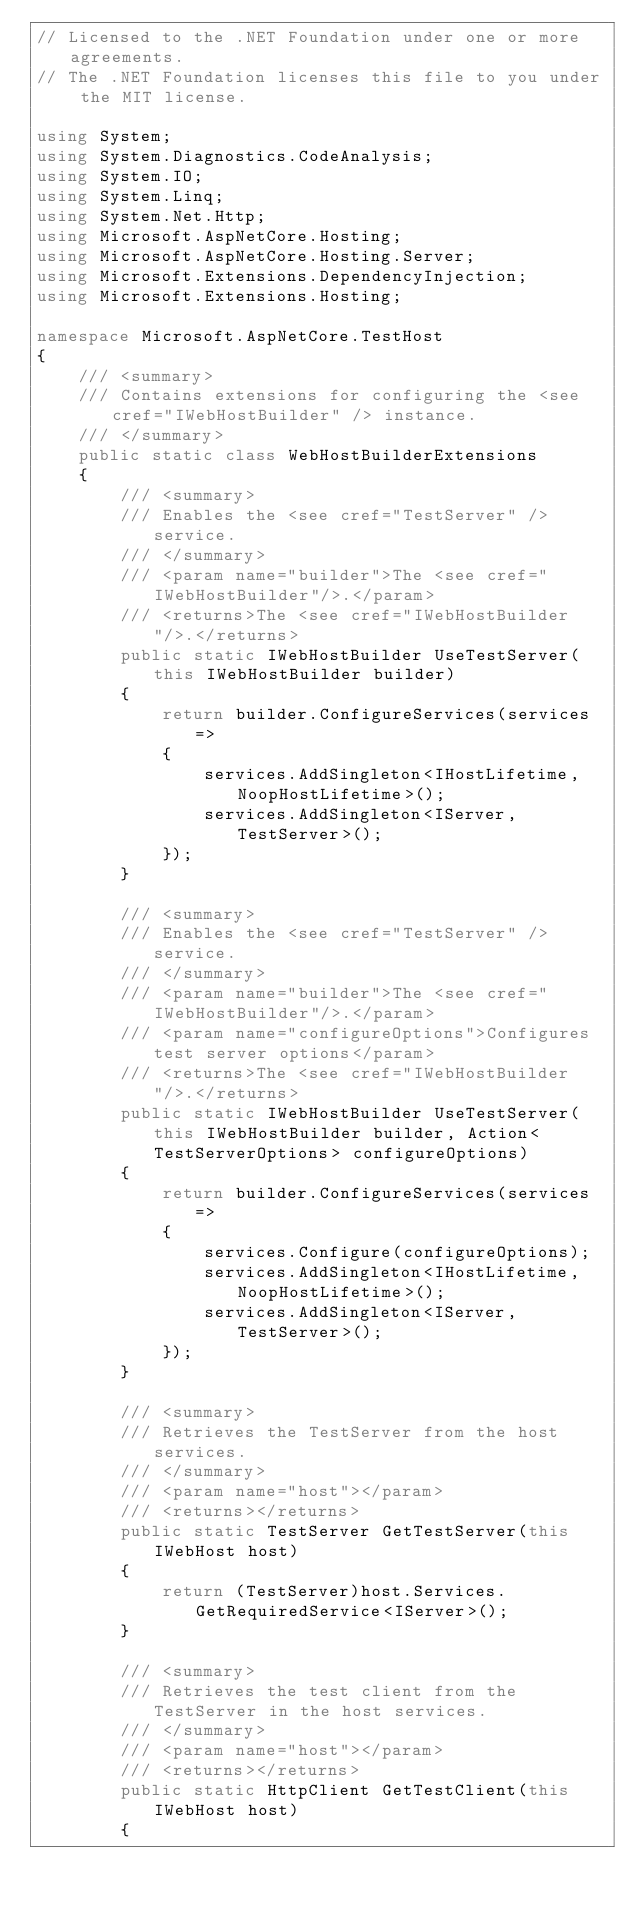Convert code to text. <code><loc_0><loc_0><loc_500><loc_500><_C#_>// Licensed to the .NET Foundation under one or more agreements.
// The .NET Foundation licenses this file to you under the MIT license.

using System;
using System.Diagnostics.CodeAnalysis;
using System.IO;
using System.Linq;
using System.Net.Http;
using Microsoft.AspNetCore.Hosting;
using Microsoft.AspNetCore.Hosting.Server;
using Microsoft.Extensions.DependencyInjection;
using Microsoft.Extensions.Hosting;

namespace Microsoft.AspNetCore.TestHost
{
    /// <summary>
    /// Contains extensions for configuring the <see cref="IWebHostBuilder" /> instance.
    /// </summary>
    public static class WebHostBuilderExtensions
    {
        /// <summary>
        /// Enables the <see cref="TestServer" /> service.
        /// </summary>
        /// <param name="builder">The <see cref="IWebHostBuilder"/>.</param>
        /// <returns>The <see cref="IWebHostBuilder"/>.</returns>
        public static IWebHostBuilder UseTestServer(this IWebHostBuilder builder)
        {
            return builder.ConfigureServices(services =>
            {
                services.AddSingleton<IHostLifetime, NoopHostLifetime>();
                services.AddSingleton<IServer, TestServer>();
            });
        }

        /// <summary>
        /// Enables the <see cref="TestServer" /> service.
        /// </summary>
        /// <param name="builder">The <see cref="IWebHostBuilder"/>.</param>
        /// <param name="configureOptions">Configures test server options</param>
        /// <returns>The <see cref="IWebHostBuilder"/>.</returns>
        public static IWebHostBuilder UseTestServer(this IWebHostBuilder builder, Action<TestServerOptions> configureOptions)
        {
            return builder.ConfigureServices(services =>
            {
                services.Configure(configureOptions);
                services.AddSingleton<IHostLifetime, NoopHostLifetime>();
                services.AddSingleton<IServer, TestServer>();
            });
        }

        /// <summary>
        /// Retrieves the TestServer from the host services.
        /// </summary>
        /// <param name="host"></param>
        /// <returns></returns>
        public static TestServer GetTestServer(this IWebHost host)
        {
            return (TestServer)host.Services.GetRequiredService<IServer>();
        }

        /// <summary>
        /// Retrieves the test client from the TestServer in the host services.
        /// </summary>
        /// <param name="host"></param>
        /// <returns></returns>
        public static HttpClient GetTestClient(this IWebHost host)
        {</code> 